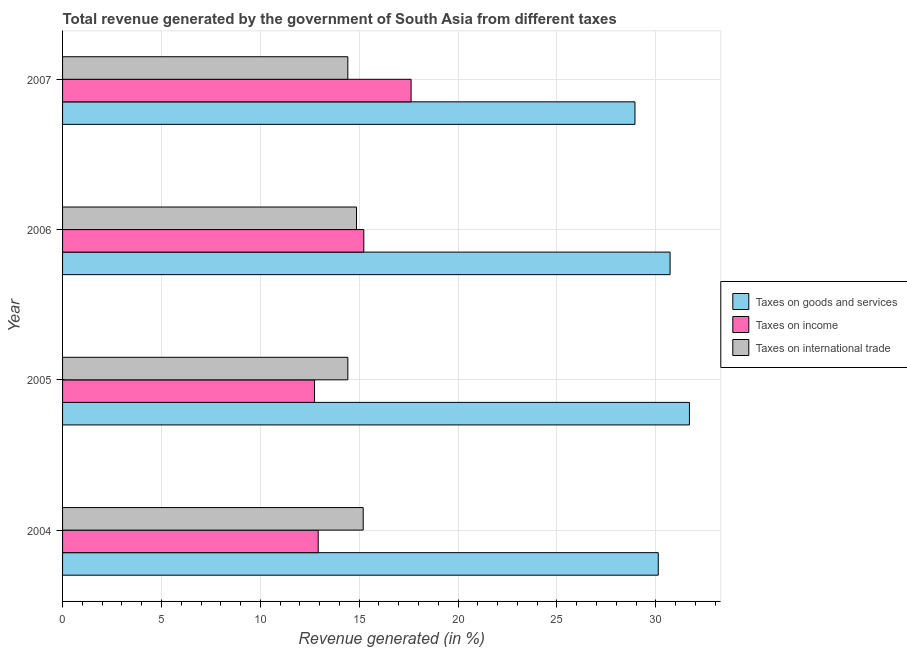How many groups of bars are there?
Offer a terse response. 4. Are the number of bars per tick equal to the number of legend labels?
Your answer should be very brief. Yes. What is the label of the 2nd group of bars from the top?
Provide a succinct answer. 2006. In how many cases, is the number of bars for a given year not equal to the number of legend labels?
Offer a terse response. 0. What is the percentage of revenue generated by taxes on income in 2007?
Give a very brief answer. 17.62. Across all years, what is the maximum percentage of revenue generated by taxes on income?
Provide a short and direct response. 17.62. Across all years, what is the minimum percentage of revenue generated by taxes on goods and services?
Provide a succinct answer. 28.94. What is the total percentage of revenue generated by taxes on income in the graph?
Offer a very short reply. 58.53. What is the difference between the percentage of revenue generated by taxes on goods and services in 2004 and that in 2005?
Provide a short and direct response. -1.58. What is the difference between the percentage of revenue generated by taxes on income in 2006 and the percentage of revenue generated by taxes on goods and services in 2004?
Ensure brevity in your answer.  -14.89. What is the average percentage of revenue generated by taxes on income per year?
Ensure brevity in your answer.  14.63. In the year 2004, what is the difference between the percentage of revenue generated by taxes on goods and services and percentage of revenue generated by tax on international trade?
Make the answer very short. 14.92. Is the difference between the percentage of revenue generated by taxes on goods and services in 2005 and 2007 greater than the difference between the percentage of revenue generated by tax on international trade in 2005 and 2007?
Keep it short and to the point. Yes. What is the difference between the highest and the second highest percentage of revenue generated by taxes on income?
Your response must be concise. 2.39. What is the difference between the highest and the lowest percentage of revenue generated by taxes on goods and services?
Your answer should be very brief. 2.76. Is the sum of the percentage of revenue generated by taxes on goods and services in 2005 and 2006 greater than the maximum percentage of revenue generated by taxes on income across all years?
Provide a succinct answer. Yes. What does the 1st bar from the top in 2005 represents?
Provide a short and direct response. Taxes on international trade. What does the 2nd bar from the bottom in 2006 represents?
Your answer should be very brief. Taxes on income. Is it the case that in every year, the sum of the percentage of revenue generated by taxes on goods and services and percentage of revenue generated by taxes on income is greater than the percentage of revenue generated by tax on international trade?
Ensure brevity in your answer.  Yes. Are all the bars in the graph horizontal?
Your response must be concise. Yes. What is the difference between two consecutive major ticks on the X-axis?
Give a very brief answer. 5. Does the graph contain grids?
Keep it short and to the point. Yes. How are the legend labels stacked?
Make the answer very short. Vertical. What is the title of the graph?
Offer a very short reply. Total revenue generated by the government of South Asia from different taxes. What is the label or title of the X-axis?
Your answer should be very brief. Revenue generated (in %). What is the label or title of the Y-axis?
Your response must be concise. Year. What is the Revenue generated (in %) in Taxes on goods and services in 2004?
Ensure brevity in your answer.  30.12. What is the Revenue generated (in %) in Taxes on income in 2004?
Offer a very short reply. 12.93. What is the Revenue generated (in %) in Taxes on international trade in 2004?
Offer a very short reply. 15.2. What is the Revenue generated (in %) of Taxes on goods and services in 2005?
Keep it short and to the point. 31.7. What is the Revenue generated (in %) of Taxes on income in 2005?
Keep it short and to the point. 12.74. What is the Revenue generated (in %) in Taxes on international trade in 2005?
Give a very brief answer. 14.43. What is the Revenue generated (in %) in Taxes on goods and services in 2006?
Make the answer very short. 30.72. What is the Revenue generated (in %) of Taxes on income in 2006?
Your response must be concise. 15.23. What is the Revenue generated (in %) of Taxes on international trade in 2006?
Offer a very short reply. 14.86. What is the Revenue generated (in %) in Taxes on goods and services in 2007?
Ensure brevity in your answer.  28.94. What is the Revenue generated (in %) in Taxes on income in 2007?
Offer a very short reply. 17.62. What is the Revenue generated (in %) of Taxes on international trade in 2007?
Provide a short and direct response. 14.42. Across all years, what is the maximum Revenue generated (in %) in Taxes on goods and services?
Provide a succinct answer. 31.7. Across all years, what is the maximum Revenue generated (in %) in Taxes on income?
Provide a succinct answer. 17.62. Across all years, what is the maximum Revenue generated (in %) of Taxes on international trade?
Provide a succinct answer. 15.2. Across all years, what is the minimum Revenue generated (in %) in Taxes on goods and services?
Give a very brief answer. 28.94. Across all years, what is the minimum Revenue generated (in %) in Taxes on income?
Your answer should be very brief. 12.74. Across all years, what is the minimum Revenue generated (in %) in Taxes on international trade?
Keep it short and to the point. 14.42. What is the total Revenue generated (in %) in Taxes on goods and services in the graph?
Offer a terse response. 121.48. What is the total Revenue generated (in %) in Taxes on income in the graph?
Offer a very short reply. 58.53. What is the total Revenue generated (in %) of Taxes on international trade in the graph?
Provide a succinct answer. 58.92. What is the difference between the Revenue generated (in %) in Taxes on goods and services in 2004 and that in 2005?
Your response must be concise. -1.58. What is the difference between the Revenue generated (in %) of Taxes on income in 2004 and that in 2005?
Provide a succinct answer. 0.19. What is the difference between the Revenue generated (in %) of Taxes on international trade in 2004 and that in 2005?
Give a very brief answer. 0.78. What is the difference between the Revenue generated (in %) of Taxes on goods and services in 2004 and that in 2006?
Give a very brief answer. -0.6. What is the difference between the Revenue generated (in %) in Taxes on income in 2004 and that in 2006?
Offer a terse response. -2.31. What is the difference between the Revenue generated (in %) of Taxes on international trade in 2004 and that in 2006?
Ensure brevity in your answer.  0.34. What is the difference between the Revenue generated (in %) of Taxes on goods and services in 2004 and that in 2007?
Give a very brief answer. 1.18. What is the difference between the Revenue generated (in %) of Taxes on income in 2004 and that in 2007?
Offer a terse response. -4.7. What is the difference between the Revenue generated (in %) in Taxes on international trade in 2004 and that in 2007?
Offer a very short reply. 0.78. What is the difference between the Revenue generated (in %) in Taxes on goods and services in 2005 and that in 2006?
Offer a very short reply. 0.98. What is the difference between the Revenue generated (in %) of Taxes on income in 2005 and that in 2006?
Provide a succinct answer. -2.49. What is the difference between the Revenue generated (in %) in Taxes on international trade in 2005 and that in 2006?
Offer a terse response. -0.44. What is the difference between the Revenue generated (in %) in Taxes on goods and services in 2005 and that in 2007?
Give a very brief answer. 2.76. What is the difference between the Revenue generated (in %) of Taxes on income in 2005 and that in 2007?
Keep it short and to the point. -4.88. What is the difference between the Revenue generated (in %) of Taxes on international trade in 2005 and that in 2007?
Provide a short and direct response. 0. What is the difference between the Revenue generated (in %) of Taxes on goods and services in 2006 and that in 2007?
Your answer should be compact. 1.78. What is the difference between the Revenue generated (in %) of Taxes on income in 2006 and that in 2007?
Provide a short and direct response. -2.39. What is the difference between the Revenue generated (in %) of Taxes on international trade in 2006 and that in 2007?
Provide a short and direct response. 0.44. What is the difference between the Revenue generated (in %) in Taxes on goods and services in 2004 and the Revenue generated (in %) in Taxes on income in 2005?
Ensure brevity in your answer.  17.38. What is the difference between the Revenue generated (in %) in Taxes on goods and services in 2004 and the Revenue generated (in %) in Taxes on international trade in 2005?
Offer a terse response. 15.7. What is the difference between the Revenue generated (in %) of Taxes on income in 2004 and the Revenue generated (in %) of Taxes on international trade in 2005?
Your answer should be very brief. -1.5. What is the difference between the Revenue generated (in %) of Taxes on goods and services in 2004 and the Revenue generated (in %) of Taxes on income in 2006?
Your answer should be compact. 14.89. What is the difference between the Revenue generated (in %) of Taxes on goods and services in 2004 and the Revenue generated (in %) of Taxes on international trade in 2006?
Ensure brevity in your answer.  15.26. What is the difference between the Revenue generated (in %) in Taxes on income in 2004 and the Revenue generated (in %) in Taxes on international trade in 2006?
Your answer should be very brief. -1.94. What is the difference between the Revenue generated (in %) of Taxes on goods and services in 2004 and the Revenue generated (in %) of Taxes on income in 2007?
Your response must be concise. 12.5. What is the difference between the Revenue generated (in %) of Taxes on goods and services in 2004 and the Revenue generated (in %) of Taxes on international trade in 2007?
Your answer should be very brief. 15.7. What is the difference between the Revenue generated (in %) in Taxes on income in 2004 and the Revenue generated (in %) in Taxes on international trade in 2007?
Give a very brief answer. -1.5. What is the difference between the Revenue generated (in %) in Taxes on goods and services in 2005 and the Revenue generated (in %) in Taxes on income in 2006?
Your answer should be very brief. 16.47. What is the difference between the Revenue generated (in %) of Taxes on goods and services in 2005 and the Revenue generated (in %) of Taxes on international trade in 2006?
Keep it short and to the point. 16.83. What is the difference between the Revenue generated (in %) of Taxes on income in 2005 and the Revenue generated (in %) of Taxes on international trade in 2006?
Your answer should be compact. -2.12. What is the difference between the Revenue generated (in %) of Taxes on goods and services in 2005 and the Revenue generated (in %) of Taxes on income in 2007?
Your answer should be very brief. 14.07. What is the difference between the Revenue generated (in %) in Taxes on goods and services in 2005 and the Revenue generated (in %) in Taxes on international trade in 2007?
Your answer should be very brief. 17.27. What is the difference between the Revenue generated (in %) in Taxes on income in 2005 and the Revenue generated (in %) in Taxes on international trade in 2007?
Offer a terse response. -1.68. What is the difference between the Revenue generated (in %) of Taxes on goods and services in 2006 and the Revenue generated (in %) of Taxes on income in 2007?
Give a very brief answer. 13.1. What is the difference between the Revenue generated (in %) of Taxes on goods and services in 2006 and the Revenue generated (in %) of Taxes on international trade in 2007?
Provide a succinct answer. 16.3. What is the difference between the Revenue generated (in %) in Taxes on income in 2006 and the Revenue generated (in %) in Taxes on international trade in 2007?
Give a very brief answer. 0.81. What is the average Revenue generated (in %) in Taxes on goods and services per year?
Ensure brevity in your answer.  30.37. What is the average Revenue generated (in %) of Taxes on income per year?
Offer a very short reply. 14.63. What is the average Revenue generated (in %) of Taxes on international trade per year?
Give a very brief answer. 14.73. In the year 2004, what is the difference between the Revenue generated (in %) of Taxes on goods and services and Revenue generated (in %) of Taxes on income?
Your answer should be compact. 17.2. In the year 2004, what is the difference between the Revenue generated (in %) of Taxes on goods and services and Revenue generated (in %) of Taxes on international trade?
Offer a terse response. 14.92. In the year 2004, what is the difference between the Revenue generated (in %) of Taxes on income and Revenue generated (in %) of Taxes on international trade?
Offer a very short reply. -2.28. In the year 2005, what is the difference between the Revenue generated (in %) of Taxes on goods and services and Revenue generated (in %) of Taxes on income?
Ensure brevity in your answer.  18.96. In the year 2005, what is the difference between the Revenue generated (in %) of Taxes on goods and services and Revenue generated (in %) of Taxes on international trade?
Provide a short and direct response. 17.27. In the year 2005, what is the difference between the Revenue generated (in %) of Taxes on income and Revenue generated (in %) of Taxes on international trade?
Give a very brief answer. -1.68. In the year 2006, what is the difference between the Revenue generated (in %) of Taxes on goods and services and Revenue generated (in %) of Taxes on income?
Provide a short and direct response. 15.49. In the year 2006, what is the difference between the Revenue generated (in %) of Taxes on goods and services and Revenue generated (in %) of Taxes on international trade?
Keep it short and to the point. 15.85. In the year 2006, what is the difference between the Revenue generated (in %) in Taxes on income and Revenue generated (in %) in Taxes on international trade?
Provide a short and direct response. 0.37. In the year 2007, what is the difference between the Revenue generated (in %) in Taxes on goods and services and Revenue generated (in %) in Taxes on income?
Your response must be concise. 11.32. In the year 2007, what is the difference between the Revenue generated (in %) of Taxes on goods and services and Revenue generated (in %) of Taxes on international trade?
Your response must be concise. 14.52. In the year 2007, what is the difference between the Revenue generated (in %) in Taxes on income and Revenue generated (in %) in Taxes on international trade?
Offer a very short reply. 3.2. What is the ratio of the Revenue generated (in %) of Taxes on goods and services in 2004 to that in 2005?
Provide a short and direct response. 0.95. What is the ratio of the Revenue generated (in %) in Taxes on income in 2004 to that in 2005?
Offer a very short reply. 1.01. What is the ratio of the Revenue generated (in %) of Taxes on international trade in 2004 to that in 2005?
Give a very brief answer. 1.05. What is the ratio of the Revenue generated (in %) in Taxes on goods and services in 2004 to that in 2006?
Provide a succinct answer. 0.98. What is the ratio of the Revenue generated (in %) in Taxes on income in 2004 to that in 2006?
Make the answer very short. 0.85. What is the ratio of the Revenue generated (in %) in Taxes on international trade in 2004 to that in 2006?
Your response must be concise. 1.02. What is the ratio of the Revenue generated (in %) of Taxes on goods and services in 2004 to that in 2007?
Provide a succinct answer. 1.04. What is the ratio of the Revenue generated (in %) of Taxes on income in 2004 to that in 2007?
Offer a terse response. 0.73. What is the ratio of the Revenue generated (in %) of Taxes on international trade in 2004 to that in 2007?
Offer a very short reply. 1.05. What is the ratio of the Revenue generated (in %) of Taxes on goods and services in 2005 to that in 2006?
Give a very brief answer. 1.03. What is the ratio of the Revenue generated (in %) in Taxes on income in 2005 to that in 2006?
Your answer should be compact. 0.84. What is the ratio of the Revenue generated (in %) of Taxes on international trade in 2005 to that in 2006?
Your answer should be compact. 0.97. What is the ratio of the Revenue generated (in %) of Taxes on goods and services in 2005 to that in 2007?
Offer a terse response. 1.1. What is the ratio of the Revenue generated (in %) in Taxes on income in 2005 to that in 2007?
Your answer should be very brief. 0.72. What is the ratio of the Revenue generated (in %) of Taxes on international trade in 2005 to that in 2007?
Provide a succinct answer. 1. What is the ratio of the Revenue generated (in %) in Taxes on goods and services in 2006 to that in 2007?
Provide a succinct answer. 1.06. What is the ratio of the Revenue generated (in %) in Taxes on income in 2006 to that in 2007?
Provide a short and direct response. 0.86. What is the ratio of the Revenue generated (in %) of Taxes on international trade in 2006 to that in 2007?
Offer a terse response. 1.03. What is the difference between the highest and the second highest Revenue generated (in %) of Taxes on goods and services?
Your response must be concise. 0.98. What is the difference between the highest and the second highest Revenue generated (in %) in Taxes on income?
Keep it short and to the point. 2.39. What is the difference between the highest and the second highest Revenue generated (in %) in Taxes on international trade?
Keep it short and to the point. 0.34. What is the difference between the highest and the lowest Revenue generated (in %) in Taxes on goods and services?
Your response must be concise. 2.76. What is the difference between the highest and the lowest Revenue generated (in %) in Taxes on income?
Your answer should be compact. 4.88. What is the difference between the highest and the lowest Revenue generated (in %) in Taxes on international trade?
Ensure brevity in your answer.  0.78. 